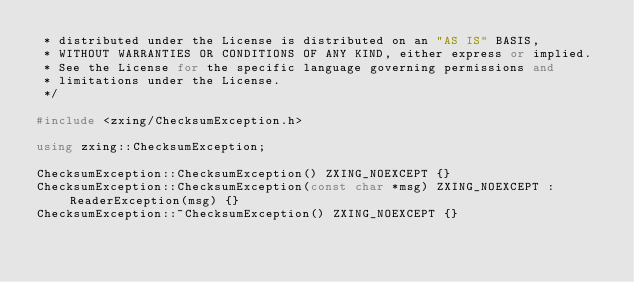<code> <loc_0><loc_0><loc_500><loc_500><_C++_> * distributed under the License is distributed on an "AS IS" BASIS,
 * WITHOUT WARRANTIES OR CONDITIONS OF ANY KIND, either express or implied.
 * See the License for the specific language governing permissions and
 * limitations under the License.
 */

#include <zxing/ChecksumException.h>

using zxing::ChecksumException;

ChecksumException::ChecksumException() ZXING_NOEXCEPT {}
ChecksumException::ChecksumException(const char *msg) ZXING_NOEXCEPT : ReaderException(msg) {}
ChecksumException::~ChecksumException() ZXING_NOEXCEPT {}
</code> 